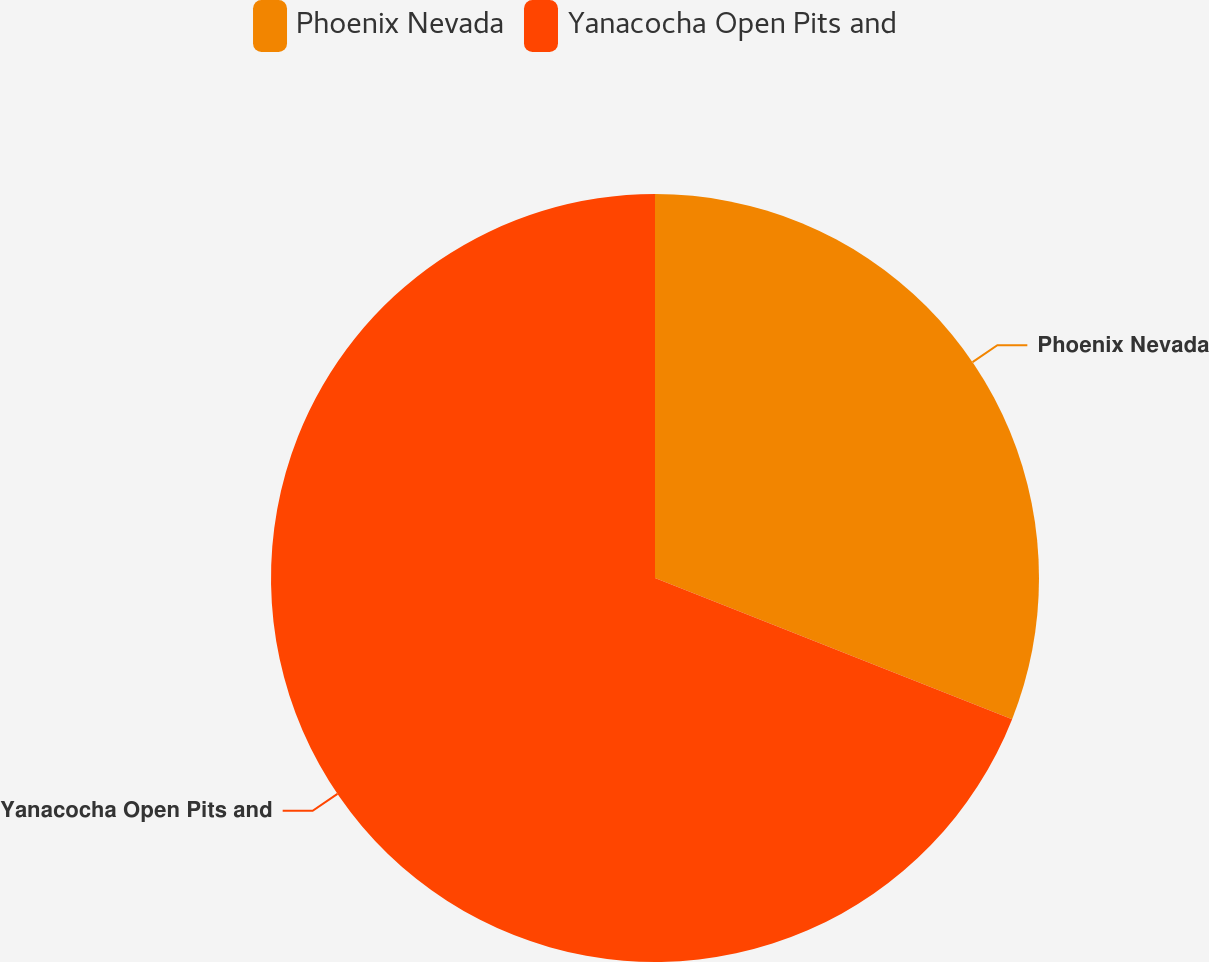Convert chart. <chart><loc_0><loc_0><loc_500><loc_500><pie_chart><fcel>Phoenix Nevada<fcel>Yanacocha Open Pits and<nl><fcel>30.99%<fcel>69.01%<nl></chart> 